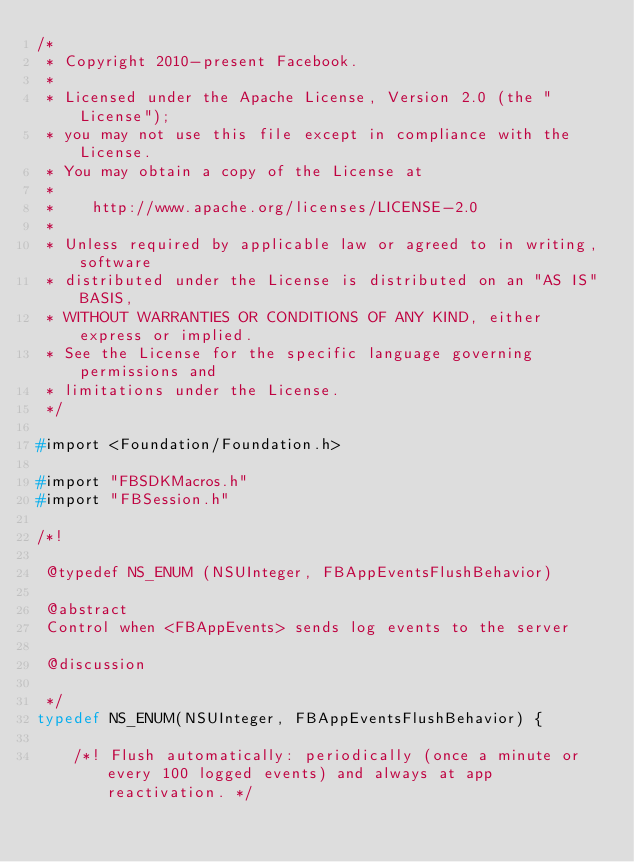Convert code to text. <code><loc_0><loc_0><loc_500><loc_500><_C_>/*
 * Copyright 2010-present Facebook.
 *
 * Licensed under the Apache License, Version 2.0 (the "License");
 * you may not use this file except in compliance with the License.
 * You may obtain a copy of the License at
 *
 *    http://www.apache.org/licenses/LICENSE-2.0
 *
 * Unless required by applicable law or agreed to in writing, software
 * distributed under the License is distributed on an "AS IS" BASIS,
 * WITHOUT WARRANTIES OR CONDITIONS OF ANY KIND, either express or implied.
 * See the License for the specific language governing permissions and
 * limitations under the License.
 */

#import <Foundation/Foundation.h>

#import "FBSDKMacros.h"
#import "FBSession.h"

/*!

 @typedef NS_ENUM (NSUInteger, FBAppEventsFlushBehavior)

 @abstract
 Control when <FBAppEvents> sends log events to the server

 @discussion

 */
typedef NS_ENUM(NSUInteger, FBAppEventsFlushBehavior) {

    /*! Flush automatically: periodically (once a minute or every 100 logged events) and always at app reactivation. */</code> 